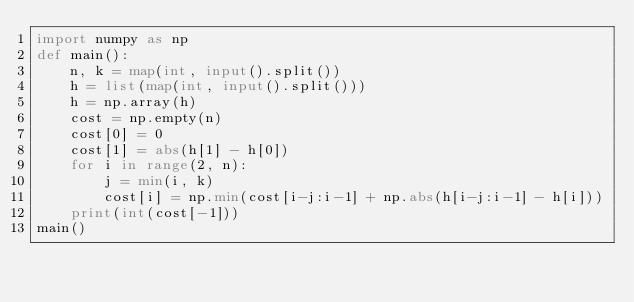<code> <loc_0><loc_0><loc_500><loc_500><_Python_>import numpy as np
def main():
    n, k = map(int, input().split())
    h = list(map(int, input().split()))
    h = np.array(h)
    cost = np.empty(n)
    cost[0] = 0
    cost[1] = abs(h[1] - h[0])
    for i in range(2, n):
        j = min(i, k)
        cost[i] = np.min(cost[i-j:i-1] + np.abs(h[i-j:i-1] - h[i]))
    print(int(cost[-1]))
main()
</code> 